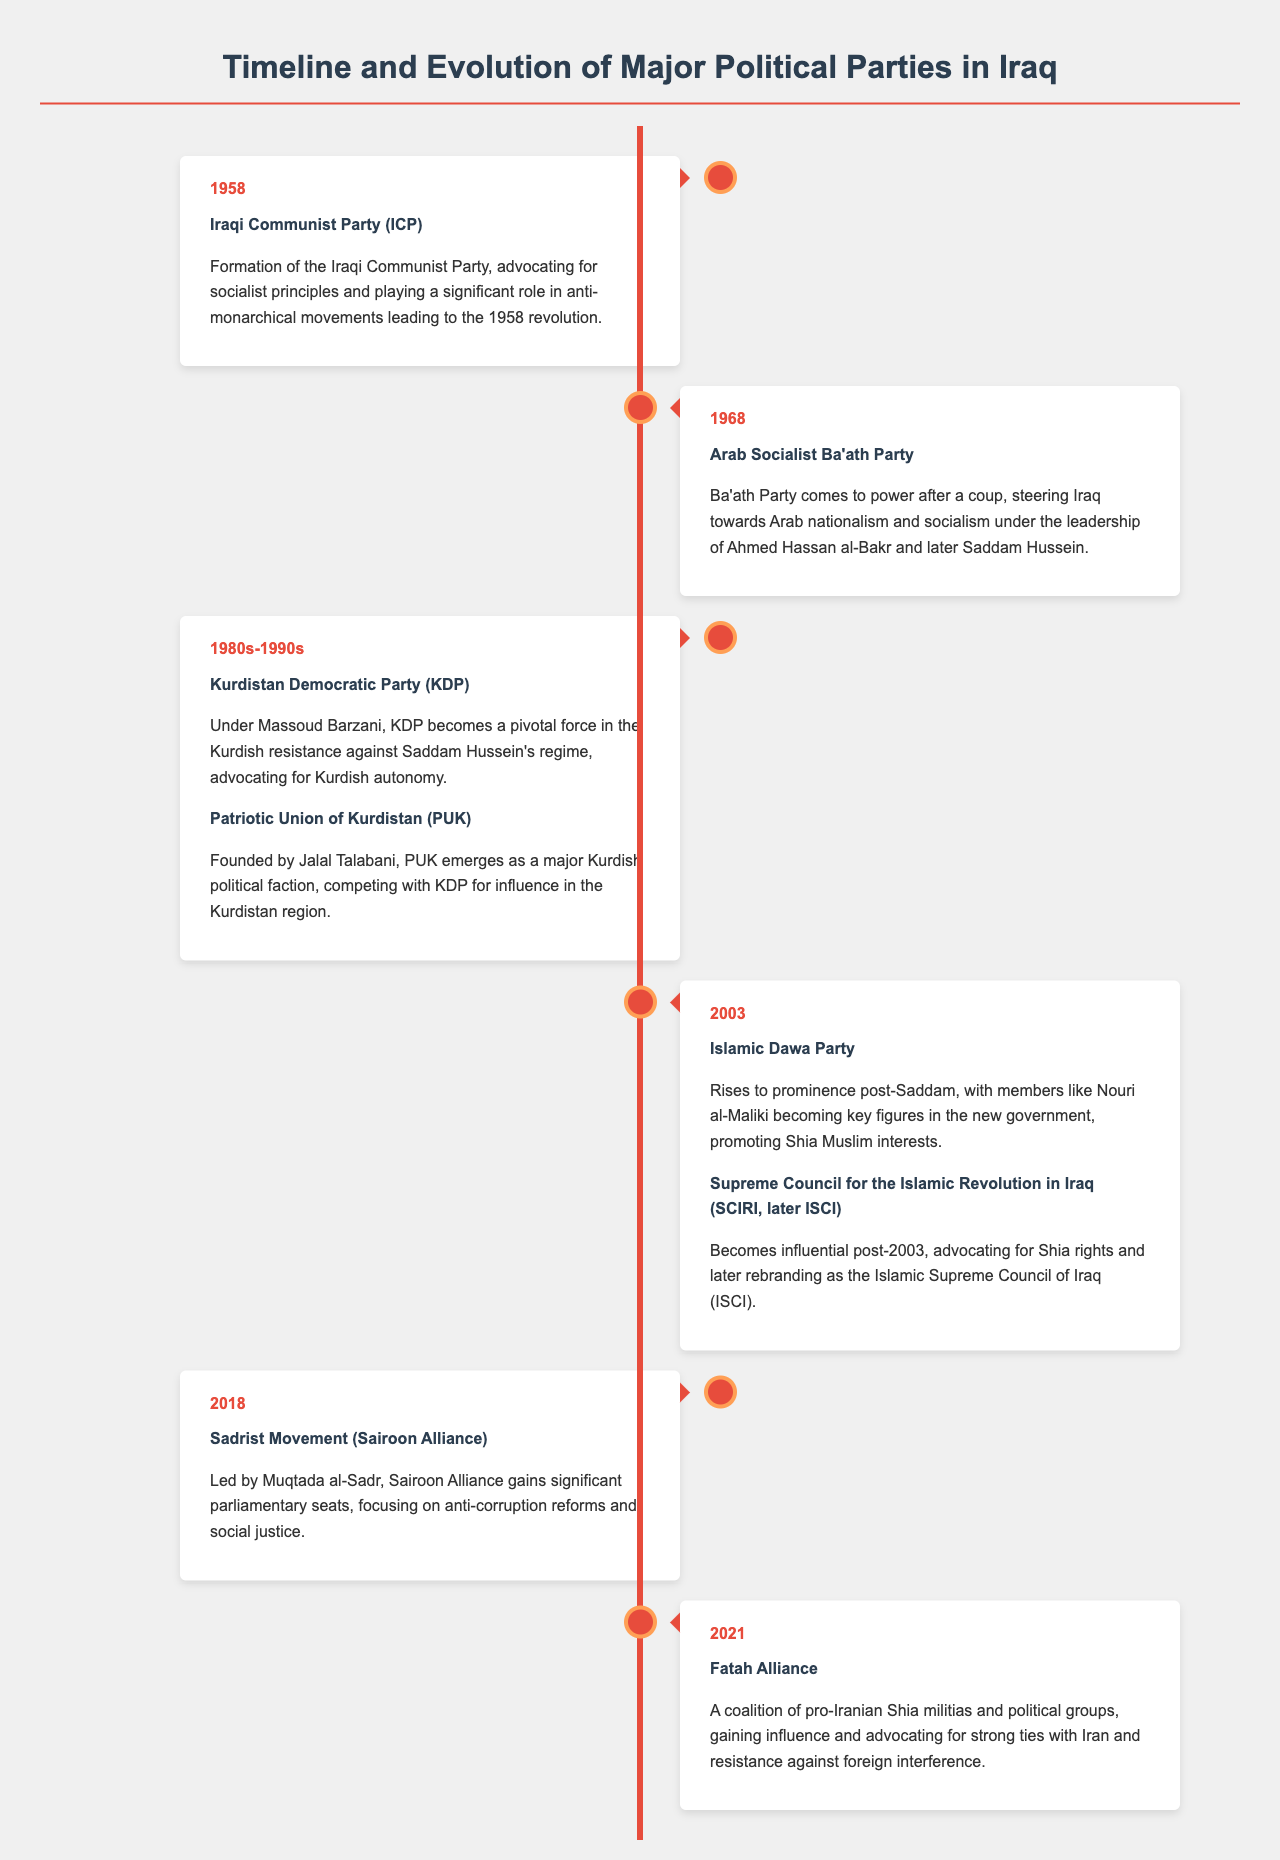What year was the Iraqi Communist Party formed? The Iraqi Communist Party was formed in 1958, as stated in the document.
Answer: 1958 Who led the Arab Socialist Ba'ath Party after the 1968 coup? The leadership of the Ba'ath Party transitioned to Ahmed Hassan al-Bakr and later Saddam Hussein.
Answer: Ahmed Hassan al-Bakr Which two Kurdish parties emerged in the 1980s and 1990s? The document states that the Kurdistan Democratic Party (KDP) and the Patriotic Union of Kurdistan (PUK) emerged as major factions.
Answer: KDP and PUK What significant political event happened in Iraq in 2003? The document indicates that multiple parties like the Islamic Dawa Party and SCIRI became prominent after the fall of Saddam Hussein in 2003.
Answer: Fall of Saddam Hussein What was the focus of the Sadrist Movement in 2018? According to the document, the Sadrist Movement led by Muqtada al-Sadr focused on anti-corruption reforms and social justice.
Answer: Anti-corruption reforms How does the Fatah Alliance relate to Iran? The Fatah Alliance is described as a coalition that advocates for strong ties with Iran.
Answer: Strong ties with Iran What type of document is this? The document is a Hierarchical infographic depicting the timeline and evolution of major political parties in Iraq.
Answer: Hierarchical infographic 